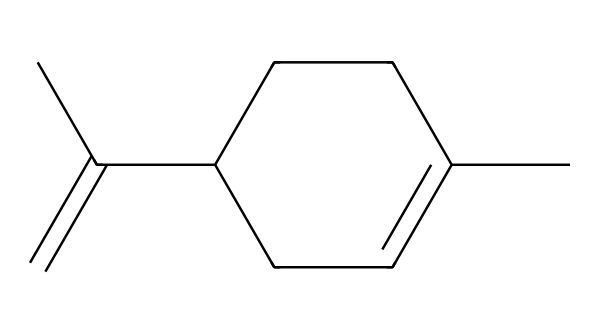What is the molecular formula of limonene? The SMILES representation can be interpreted by counting each type of atom present. In this case, there are 10 carbon atoms (C) and 16 hydrogen atoms (H), which leads to the molecular formula C10H16.
Answer: C10H16 How many double bonds does limonene have? By examining the SMILES representation, we see two double bonds (indicated by the '=' symbol) in the structure. One is in the cyclic portion and the other is in the side chain.
Answer: 2 What type of geometric isomers can limonene exhibit? Limonene can exhibit cis-trans isomerism due to the presence of double bonds in its structure. The stereochemistry around these double bonds allows for different spatial arrangements.
Answer: cis-trans Which configuration indicates the presence of the citrus scent in limonene? The S-configured structure of limonene is known for its characteristic citrus scent, specifically the trans-isomer (or R)-limonene, which is often associated with the aroma of citrus fruits.
Answer: S-configured Can limonene exist in both ring and open-chain forms? Limonene is predominantly found in a cyclic structure in natural sources, but it can be converted to an open-chain form under certain conditions. However, the most common and stable form in nature is the cyclic one.
Answer: Yes 